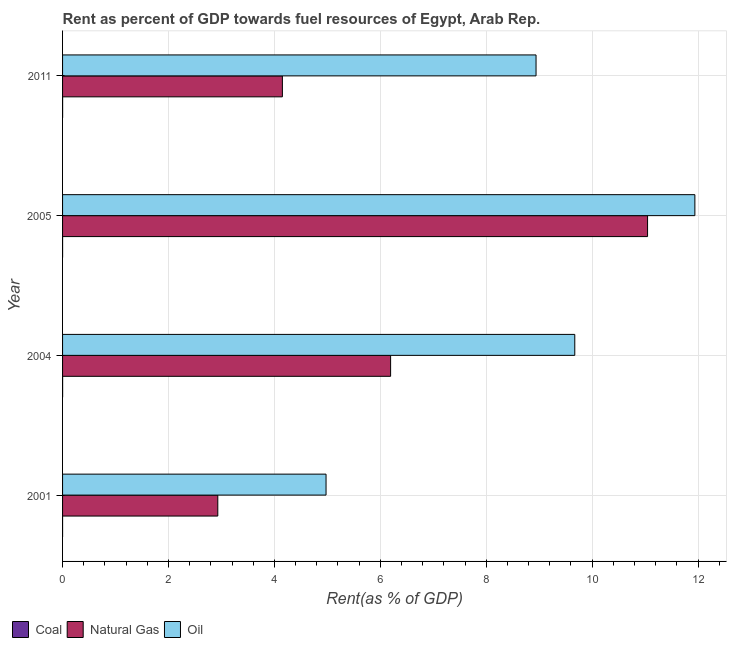How many groups of bars are there?
Offer a terse response. 4. Are the number of bars on each tick of the Y-axis equal?
Make the answer very short. Yes. How many bars are there on the 4th tick from the top?
Keep it short and to the point. 3. What is the label of the 3rd group of bars from the top?
Offer a very short reply. 2004. What is the rent towards natural gas in 2005?
Keep it short and to the point. 11.05. Across all years, what is the maximum rent towards coal?
Your answer should be compact. 0. Across all years, what is the minimum rent towards oil?
Your answer should be compact. 4.98. What is the total rent towards natural gas in the graph?
Offer a terse response. 24.32. What is the difference between the rent towards oil in 2001 and that in 2004?
Offer a very short reply. -4.7. What is the difference between the rent towards coal in 2005 and the rent towards oil in 2011?
Offer a very short reply. -8.94. In the year 2001, what is the difference between the rent towards coal and rent towards oil?
Your response must be concise. -4.97. What is the ratio of the rent towards coal in 2004 to that in 2011?
Offer a very short reply. 1.12. Is the difference between the rent towards coal in 2001 and 2011 greater than the difference between the rent towards natural gas in 2001 and 2011?
Your answer should be very brief. Yes. What is the difference between the highest and the lowest rent towards natural gas?
Your answer should be compact. 8.12. Is the sum of the rent towards natural gas in 2004 and 2005 greater than the maximum rent towards oil across all years?
Offer a very short reply. Yes. What does the 3rd bar from the top in 2011 represents?
Provide a short and direct response. Coal. What does the 3rd bar from the bottom in 2001 represents?
Offer a terse response. Oil. Is it the case that in every year, the sum of the rent towards coal and rent towards natural gas is greater than the rent towards oil?
Ensure brevity in your answer.  No. Are all the bars in the graph horizontal?
Offer a very short reply. Yes. How many years are there in the graph?
Provide a short and direct response. 4. What is the difference between two consecutive major ticks on the X-axis?
Offer a terse response. 2. Does the graph contain any zero values?
Your answer should be very brief. No. Does the graph contain grids?
Provide a short and direct response. Yes. What is the title of the graph?
Keep it short and to the point. Rent as percent of GDP towards fuel resources of Egypt, Arab Rep. What is the label or title of the X-axis?
Keep it short and to the point. Rent(as % of GDP). What is the Rent(as % of GDP) in Coal in 2001?
Your answer should be very brief. 1.02739128441411e-6. What is the Rent(as % of GDP) in Natural Gas in 2001?
Offer a terse response. 2.93. What is the Rent(as % of GDP) of Oil in 2001?
Offer a terse response. 4.98. What is the Rent(as % of GDP) of Coal in 2004?
Provide a short and direct response. 0. What is the Rent(as % of GDP) of Natural Gas in 2004?
Provide a short and direct response. 6.19. What is the Rent(as % of GDP) in Oil in 2004?
Offer a terse response. 9.67. What is the Rent(as % of GDP) of Coal in 2005?
Provide a short and direct response. 0. What is the Rent(as % of GDP) of Natural Gas in 2005?
Your response must be concise. 11.05. What is the Rent(as % of GDP) of Oil in 2005?
Offer a very short reply. 11.94. What is the Rent(as % of GDP) in Coal in 2011?
Give a very brief answer. 0. What is the Rent(as % of GDP) of Natural Gas in 2011?
Your answer should be compact. 4.15. What is the Rent(as % of GDP) of Oil in 2011?
Ensure brevity in your answer.  8.94. Across all years, what is the maximum Rent(as % of GDP) in Coal?
Ensure brevity in your answer.  0. Across all years, what is the maximum Rent(as % of GDP) in Natural Gas?
Provide a short and direct response. 11.05. Across all years, what is the maximum Rent(as % of GDP) of Oil?
Your response must be concise. 11.94. Across all years, what is the minimum Rent(as % of GDP) in Coal?
Keep it short and to the point. 1.02739128441411e-6. Across all years, what is the minimum Rent(as % of GDP) in Natural Gas?
Your answer should be compact. 2.93. Across all years, what is the minimum Rent(as % of GDP) in Oil?
Your answer should be compact. 4.98. What is the total Rent(as % of GDP) in Coal in the graph?
Provide a succinct answer. 0. What is the total Rent(as % of GDP) of Natural Gas in the graph?
Provide a short and direct response. 24.32. What is the total Rent(as % of GDP) of Oil in the graph?
Provide a short and direct response. 35.53. What is the difference between the Rent(as % of GDP) of Coal in 2001 and that in 2004?
Your answer should be compact. -0. What is the difference between the Rent(as % of GDP) in Natural Gas in 2001 and that in 2004?
Provide a succinct answer. -3.26. What is the difference between the Rent(as % of GDP) of Oil in 2001 and that in 2004?
Offer a very short reply. -4.7. What is the difference between the Rent(as % of GDP) of Coal in 2001 and that in 2005?
Your answer should be very brief. -0. What is the difference between the Rent(as % of GDP) of Natural Gas in 2001 and that in 2005?
Offer a terse response. -8.12. What is the difference between the Rent(as % of GDP) in Oil in 2001 and that in 2005?
Your response must be concise. -6.96. What is the difference between the Rent(as % of GDP) of Coal in 2001 and that in 2011?
Offer a very short reply. -0. What is the difference between the Rent(as % of GDP) of Natural Gas in 2001 and that in 2011?
Keep it short and to the point. -1.22. What is the difference between the Rent(as % of GDP) of Oil in 2001 and that in 2011?
Give a very brief answer. -3.97. What is the difference between the Rent(as % of GDP) of Coal in 2004 and that in 2005?
Give a very brief answer. 0. What is the difference between the Rent(as % of GDP) in Natural Gas in 2004 and that in 2005?
Make the answer very short. -4.85. What is the difference between the Rent(as % of GDP) in Oil in 2004 and that in 2005?
Your answer should be very brief. -2.27. What is the difference between the Rent(as % of GDP) in Natural Gas in 2004 and that in 2011?
Give a very brief answer. 2.04. What is the difference between the Rent(as % of GDP) of Oil in 2004 and that in 2011?
Give a very brief answer. 0.73. What is the difference between the Rent(as % of GDP) in Coal in 2005 and that in 2011?
Provide a short and direct response. -0. What is the difference between the Rent(as % of GDP) in Natural Gas in 2005 and that in 2011?
Your response must be concise. 6.9. What is the difference between the Rent(as % of GDP) in Oil in 2005 and that in 2011?
Make the answer very short. 3. What is the difference between the Rent(as % of GDP) in Coal in 2001 and the Rent(as % of GDP) in Natural Gas in 2004?
Keep it short and to the point. -6.19. What is the difference between the Rent(as % of GDP) of Coal in 2001 and the Rent(as % of GDP) of Oil in 2004?
Keep it short and to the point. -9.67. What is the difference between the Rent(as % of GDP) in Natural Gas in 2001 and the Rent(as % of GDP) in Oil in 2004?
Provide a succinct answer. -6.74. What is the difference between the Rent(as % of GDP) in Coal in 2001 and the Rent(as % of GDP) in Natural Gas in 2005?
Offer a very short reply. -11.05. What is the difference between the Rent(as % of GDP) of Coal in 2001 and the Rent(as % of GDP) of Oil in 2005?
Ensure brevity in your answer.  -11.94. What is the difference between the Rent(as % of GDP) in Natural Gas in 2001 and the Rent(as % of GDP) in Oil in 2005?
Provide a short and direct response. -9.01. What is the difference between the Rent(as % of GDP) of Coal in 2001 and the Rent(as % of GDP) of Natural Gas in 2011?
Make the answer very short. -4.15. What is the difference between the Rent(as % of GDP) in Coal in 2001 and the Rent(as % of GDP) in Oil in 2011?
Make the answer very short. -8.94. What is the difference between the Rent(as % of GDP) in Natural Gas in 2001 and the Rent(as % of GDP) in Oil in 2011?
Offer a very short reply. -6.01. What is the difference between the Rent(as % of GDP) of Coal in 2004 and the Rent(as % of GDP) of Natural Gas in 2005?
Give a very brief answer. -11.05. What is the difference between the Rent(as % of GDP) in Coal in 2004 and the Rent(as % of GDP) in Oil in 2005?
Make the answer very short. -11.94. What is the difference between the Rent(as % of GDP) of Natural Gas in 2004 and the Rent(as % of GDP) of Oil in 2005?
Make the answer very short. -5.75. What is the difference between the Rent(as % of GDP) in Coal in 2004 and the Rent(as % of GDP) in Natural Gas in 2011?
Your answer should be very brief. -4.15. What is the difference between the Rent(as % of GDP) of Coal in 2004 and the Rent(as % of GDP) of Oil in 2011?
Keep it short and to the point. -8.94. What is the difference between the Rent(as % of GDP) of Natural Gas in 2004 and the Rent(as % of GDP) of Oil in 2011?
Provide a short and direct response. -2.75. What is the difference between the Rent(as % of GDP) of Coal in 2005 and the Rent(as % of GDP) of Natural Gas in 2011?
Your answer should be very brief. -4.15. What is the difference between the Rent(as % of GDP) in Coal in 2005 and the Rent(as % of GDP) in Oil in 2011?
Your answer should be compact. -8.94. What is the difference between the Rent(as % of GDP) in Natural Gas in 2005 and the Rent(as % of GDP) in Oil in 2011?
Make the answer very short. 2.11. What is the average Rent(as % of GDP) in Coal per year?
Make the answer very short. 0. What is the average Rent(as % of GDP) in Natural Gas per year?
Your answer should be compact. 6.08. What is the average Rent(as % of GDP) in Oil per year?
Your answer should be compact. 8.88. In the year 2001, what is the difference between the Rent(as % of GDP) in Coal and Rent(as % of GDP) in Natural Gas?
Provide a succinct answer. -2.93. In the year 2001, what is the difference between the Rent(as % of GDP) in Coal and Rent(as % of GDP) in Oil?
Ensure brevity in your answer.  -4.98. In the year 2001, what is the difference between the Rent(as % of GDP) of Natural Gas and Rent(as % of GDP) of Oil?
Offer a terse response. -2.04. In the year 2004, what is the difference between the Rent(as % of GDP) of Coal and Rent(as % of GDP) of Natural Gas?
Give a very brief answer. -6.19. In the year 2004, what is the difference between the Rent(as % of GDP) in Coal and Rent(as % of GDP) in Oil?
Provide a short and direct response. -9.67. In the year 2004, what is the difference between the Rent(as % of GDP) in Natural Gas and Rent(as % of GDP) in Oil?
Make the answer very short. -3.48. In the year 2005, what is the difference between the Rent(as % of GDP) in Coal and Rent(as % of GDP) in Natural Gas?
Ensure brevity in your answer.  -11.05. In the year 2005, what is the difference between the Rent(as % of GDP) of Coal and Rent(as % of GDP) of Oil?
Your answer should be very brief. -11.94. In the year 2005, what is the difference between the Rent(as % of GDP) of Natural Gas and Rent(as % of GDP) of Oil?
Provide a short and direct response. -0.89. In the year 2011, what is the difference between the Rent(as % of GDP) in Coal and Rent(as % of GDP) in Natural Gas?
Ensure brevity in your answer.  -4.15. In the year 2011, what is the difference between the Rent(as % of GDP) of Coal and Rent(as % of GDP) of Oil?
Offer a terse response. -8.94. In the year 2011, what is the difference between the Rent(as % of GDP) in Natural Gas and Rent(as % of GDP) in Oil?
Your response must be concise. -4.79. What is the ratio of the Rent(as % of GDP) of Coal in 2001 to that in 2004?
Your response must be concise. 0. What is the ratio of the Rent(as % of GDP) in Natural Gas in 2001 to that in 2004?
Make the answer very short. 0.47. What is the ratio of the Rent(as % of GDP) of Oil in 2001 to that in 2004?
Offer a terse response. 0.51. What is the ratio of the Rent(as % of GDP) of Coal in 2001 to that in 2005?
Your answer should be compact. 0. What is the ratio of the Rent(as % of GDP) in Natural Gas in 2001 to that in 2005?
Give a very brief answer. 0.27. What is the ratio of the Rent(as % of GDP) in Oil in 2001 to that in 2005?
Your answer should be very brief. 0.42. What is the ratio of the Rent(as % of GDP) of Coal in 2001 to that in 2011?
Provide a short and direct response. 0. What is the ratio of the Rent(as % of GDP) of Natural Gas in 2001 to that in 2011?
Your answer should be compact. 0.71. What is the ratio of the Rent(as % of GDP) of Oil in 2001 to that in 2011?
Your answer should be very brief. 0.56. What is the ratio of the Rent(as % of GDP) in Coal in 2004 to that in 2005?
Your answer should be very brief. 2.83. What is the ratio of the Rent(as % of GDP) of Natural Gas in 2004 to that in 2005?
Your response must be concise. 0.56. What is the ratio of the Rent(as % of GDP) of Oil in 2004 to that in 2005?
Provide a succinct answer. 0.81. What is the ratio of the Rent(as % of GDP) in Coal in 2004 to that in 2011?
Make the answer very short. 1.13. What is the ratio of the Rent(as % of GDP) of Natural Gas in 2004 to that in 2011?
Keep it short and to the point. 1.49. What is the ratio of the Rent(as % of GDP) of Oil in 2004 to that in 2011?
Ensure brevity in your answer.  1.08. What is the ratio of the Rent(as % of GDP) in Coal in 2005 to that in 2011?
Give a very brief answer. 0.4. What is the ratio of the Rent(as % of GDP) of Natural Gas in 2005 to that in 2011?
Give a very brief answer. 2.66. What is the ratio of the Rent(as % of GDP) of Oil in 2005 to that in 2011?
Provide a short and direct response. 1.34. What is the difference between the highest and the second highest Rent(as % of GDP) of Natural Gas?
Keep it short and to the point. 4.85. What is the difference between the highest and the second highest Rent(as % of GDP) in Oil?
Give a very brief answer. 2.27. What is the difference between the highest and the lowest Rent(as % of GDP) in Coal?
Ensure brevity in your answer.  0. What is the difference between the highest and the lowest Rent(as % of GDP) of Natural Gas?
Provide a succinct answer. 8.12. What is the difference between the highest and the lowest Rent(as % of GDP) in Oil?
Your answer should be compact. 6.96. 